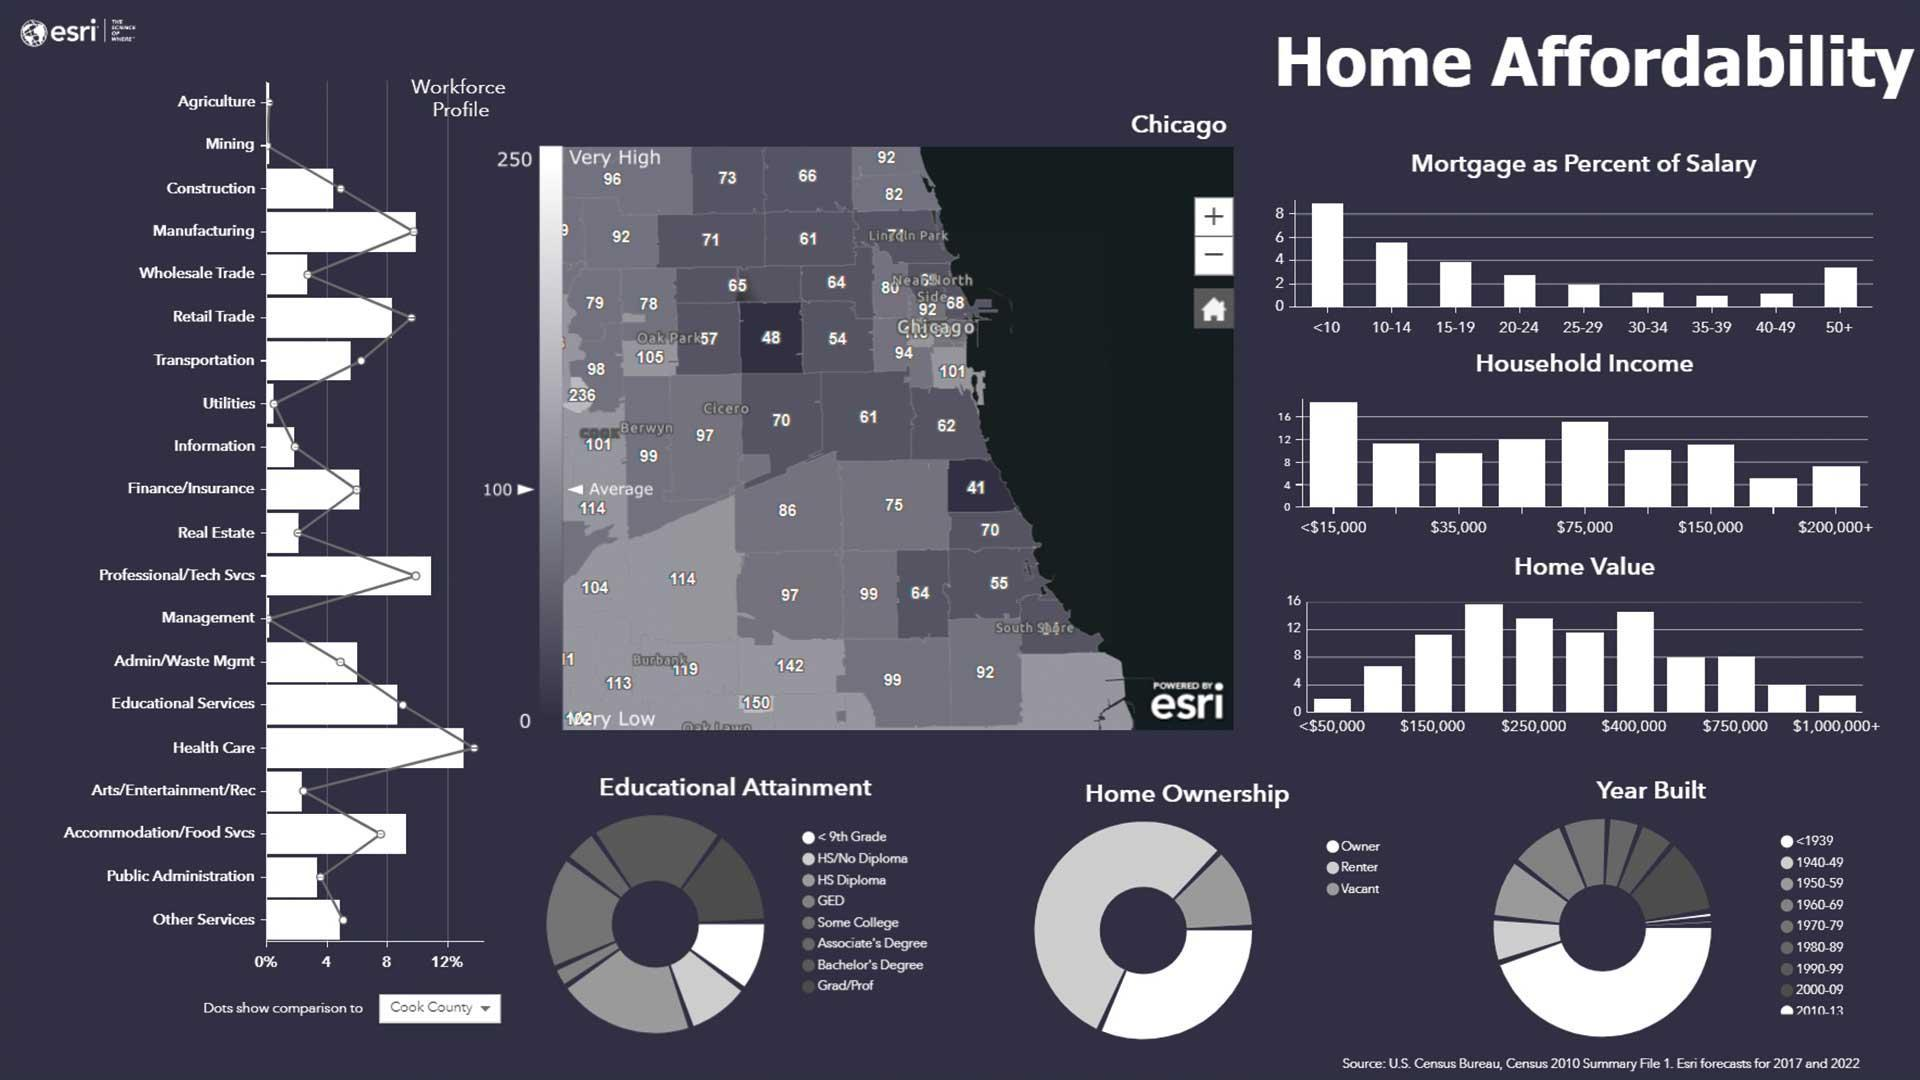The maximum number of  home ownership lies in which category, Owner, Renter, or Vacant?
Answer the question with a short phrase. Renter Which time period shows when the maximum number of houses were built? 2010-13 How  any workforce profiles are listed? 20 How many categories is the Home ownership divided into ? 3 